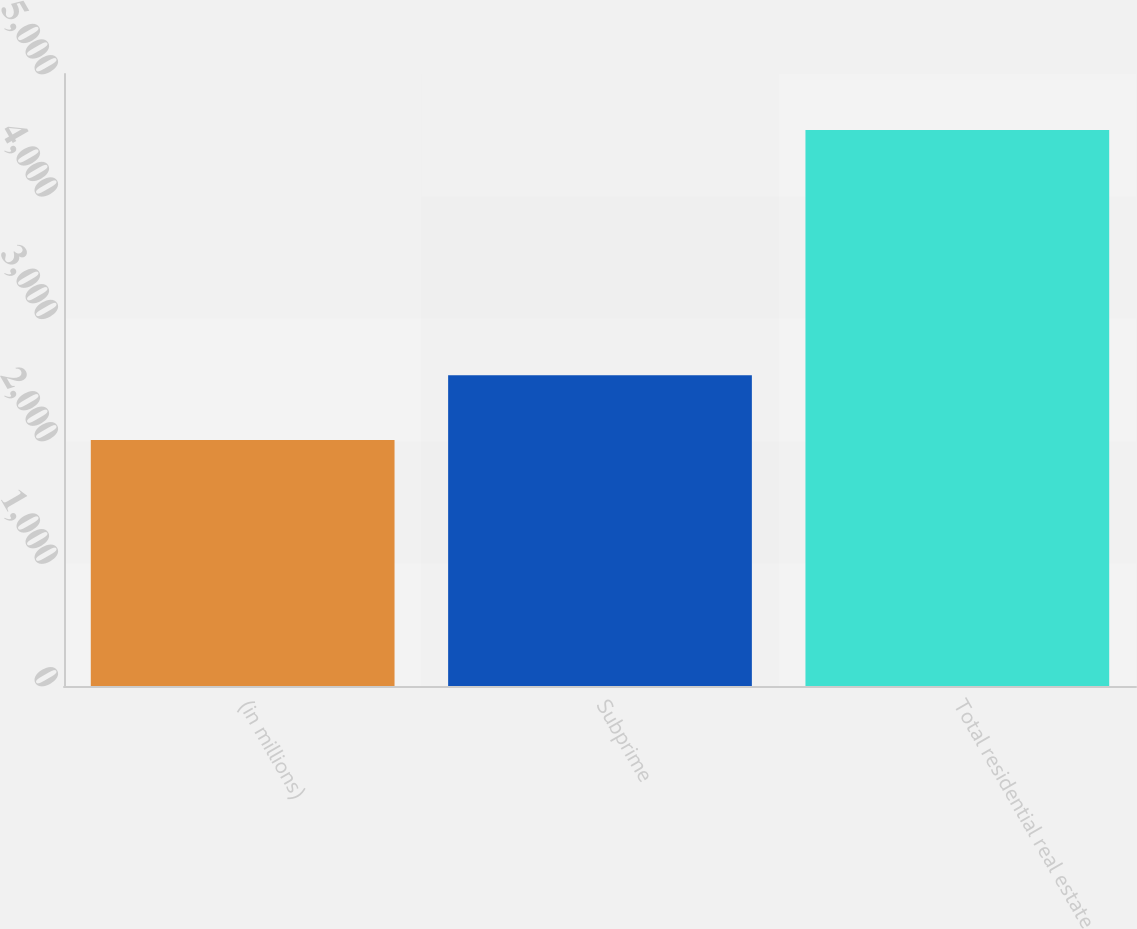Convert chart. <chart><loc_0><loc_0><loc_500><loc_500><bar_chart><fcel>(in millions)<fcel>Subprime<fcel>Total residential real estate<nl><fcel>2010<fcel>2539<fcel>4542<nl></chart> 